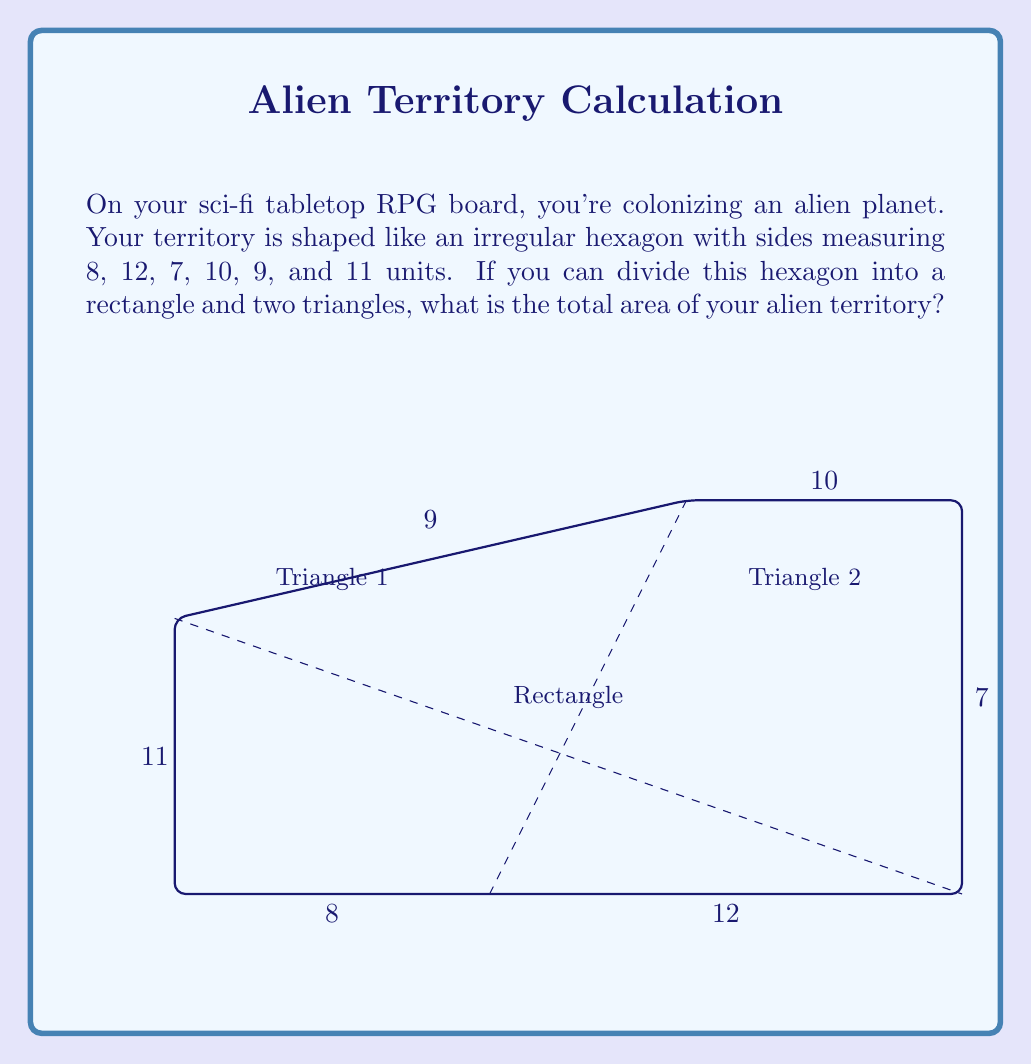Can you answer this question? Let's approach this step-by-step:

1) First, we need to identify the dimensions of the rectangle and two triangles:
   - The rectangle has a width of 12 units (the longest side) and a height of 10 units (the second longest side).
   - Triangle 1 has a base of 8 units and a height of 7 units.
   - Triangle 2 has a base of 8 units (20 - 12) and a height of 10 units.

2) Calculate the area of the rectangle:
   $A_{rectangle} = length * width = 12 * 10 = 120$ square units

3) Calculate the area of Triangle 1:
   $A_{triangle1} = \frac{1}{2} * base * height = \frac{1}{2} * 8 * 7 = 28$ square units

4) Calculate the area of Triangle 2:
   $A_{triangle2} = \frac{1}{2} * base * height = \frac{1}{2} * 8 * 10 = 40$ square units

5) Sum up all areas:
   $A_{total} = A_{rectangle} + A_{triangle1} + A_{triangle2}$
   $A_{total} = 120 + 28 + 40 = 188$ square units

Therefore, the total area of your alien territory is 188 square units.
Answer: 188 square units 